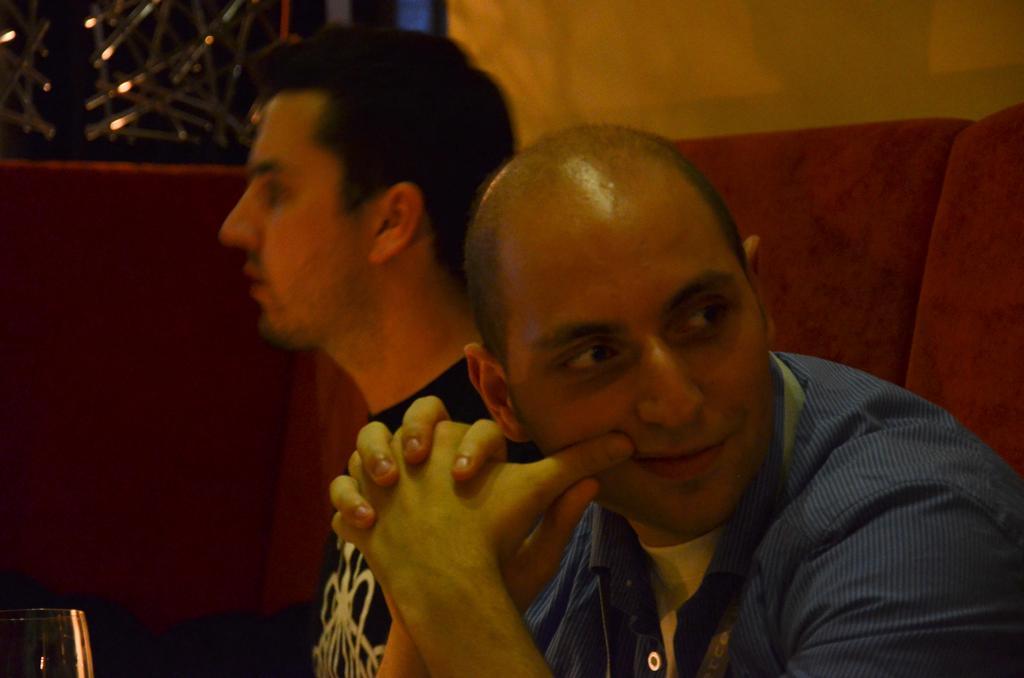How would you summarize this image in a sentence or two? In this picture we can see two men sitting here, at the left bottom we can see a glass, there is a wall here. 